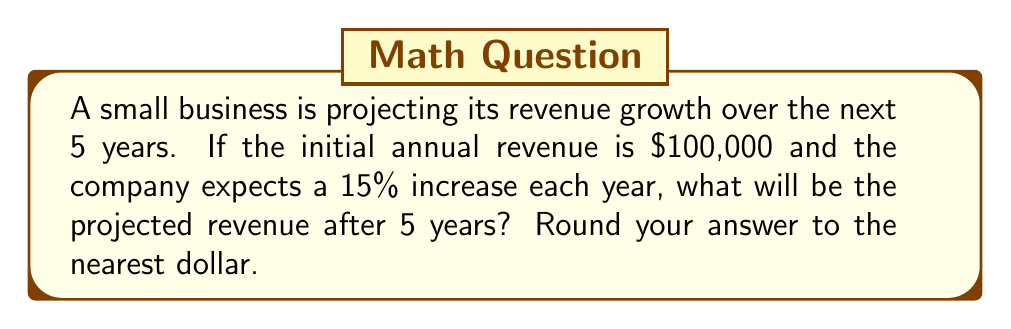Help me with this question. Let's approach this step-by-step:

1) The initial revenue is $100,000, and it's increasing by 15% each year.

2) This scenario represents exponential growth, where the general formula is:
   
   $A = P(1 + r)^t$

   Where:
   $A$ = Final amount
   $P$ = Initial principal balance
   $r$ = Annual growth rate (in decimal form)
   $t$ = Number of years

3) In this case:
   $P = 100,000$
   $r = 15\% = 0.15$
   $t = 5$ years

4) Let's plug these values into our formula:

   $A = 100,000(1 + 0.15)^5$

5) Simplify inside the parentheses:
   
   $A = 100,000(1.15)^5$

6) Calculate the exponent:
   
   $A = 100,000 * 2.0113689$

7) Multiply:
   
   $A = 201,136.89$

8) Rounding to the nearest dollar:
   
   $A = 201,137$

Therefore, the projected revenue after 5 years will be $201,137.
Answer: $201,137 